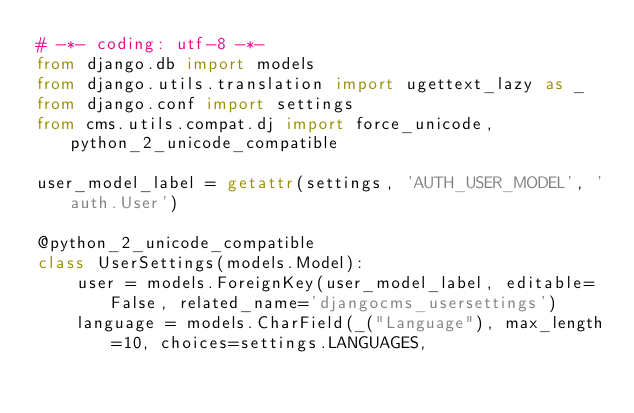<code> <loc_0><loc_0><loc_500><loc_500><_Python_># -*- coding: utf-8 -*-
from django.db import models
from django.utils.translation import ugettext_lazy as _
from django.conf import settings
from cms.utils.compat.dj import force_unicode, python_2_unicode_compatible

user_model_label = getattr(settings, 'AUTH_USER_MODEL', 'auth.User')

@python_2_unicode_compatible
class UserSettings(models.Model):
    user = models.ForeignKey(user_model_label, editable=False, related_name='djangocms_usersettings')
    language = models.CharField(_("Language"), max_length=10, choices=settings.LANGUAGES,</code> 